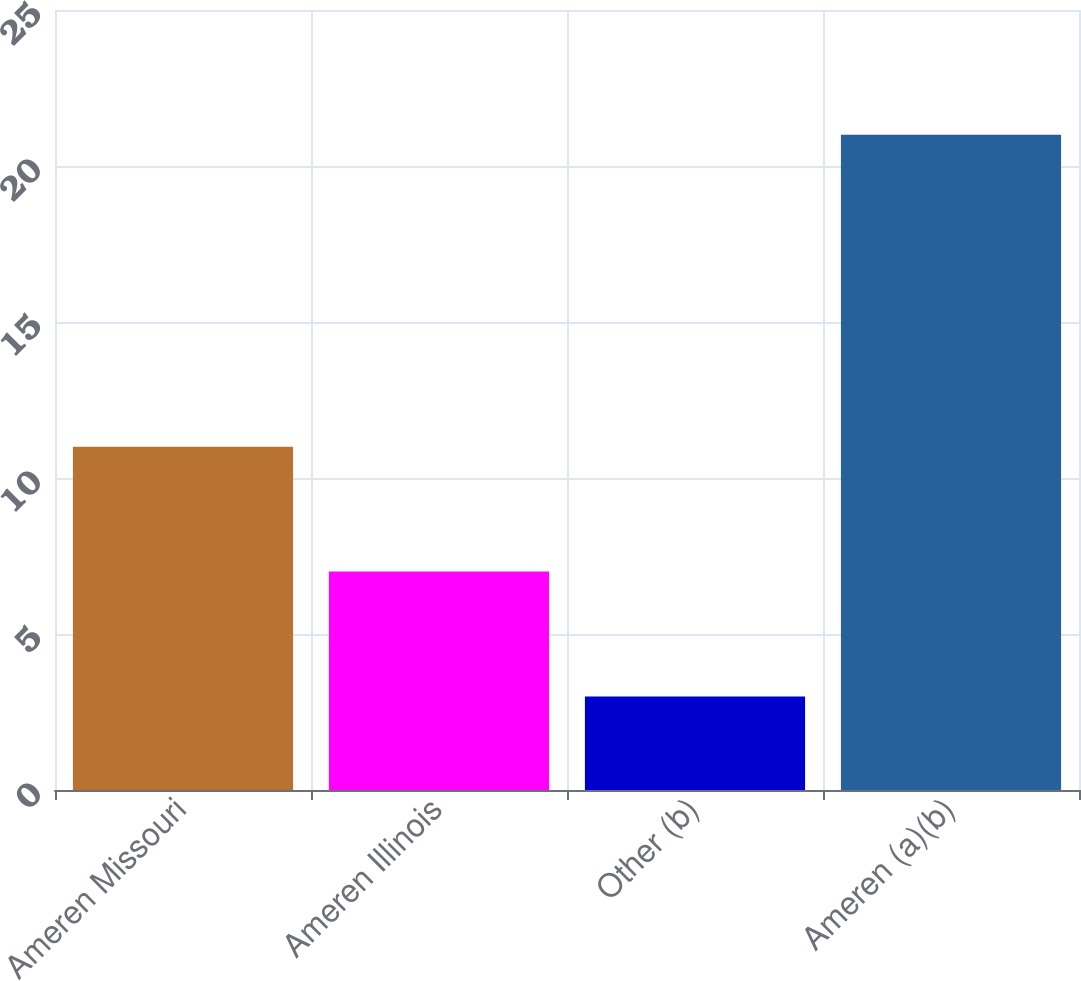Convert chart to OTSL. <chart><loc_0><loc_0><loc_500><loc_500><bar_chart><fcel>Ameren Missouri<fcel>Ameren Illinois<fcel>Other (b)<fcel>Ameren (a)(b)<nl><fcel>11<fcel>7<fcel>3<fcel>21<nl></chart> 